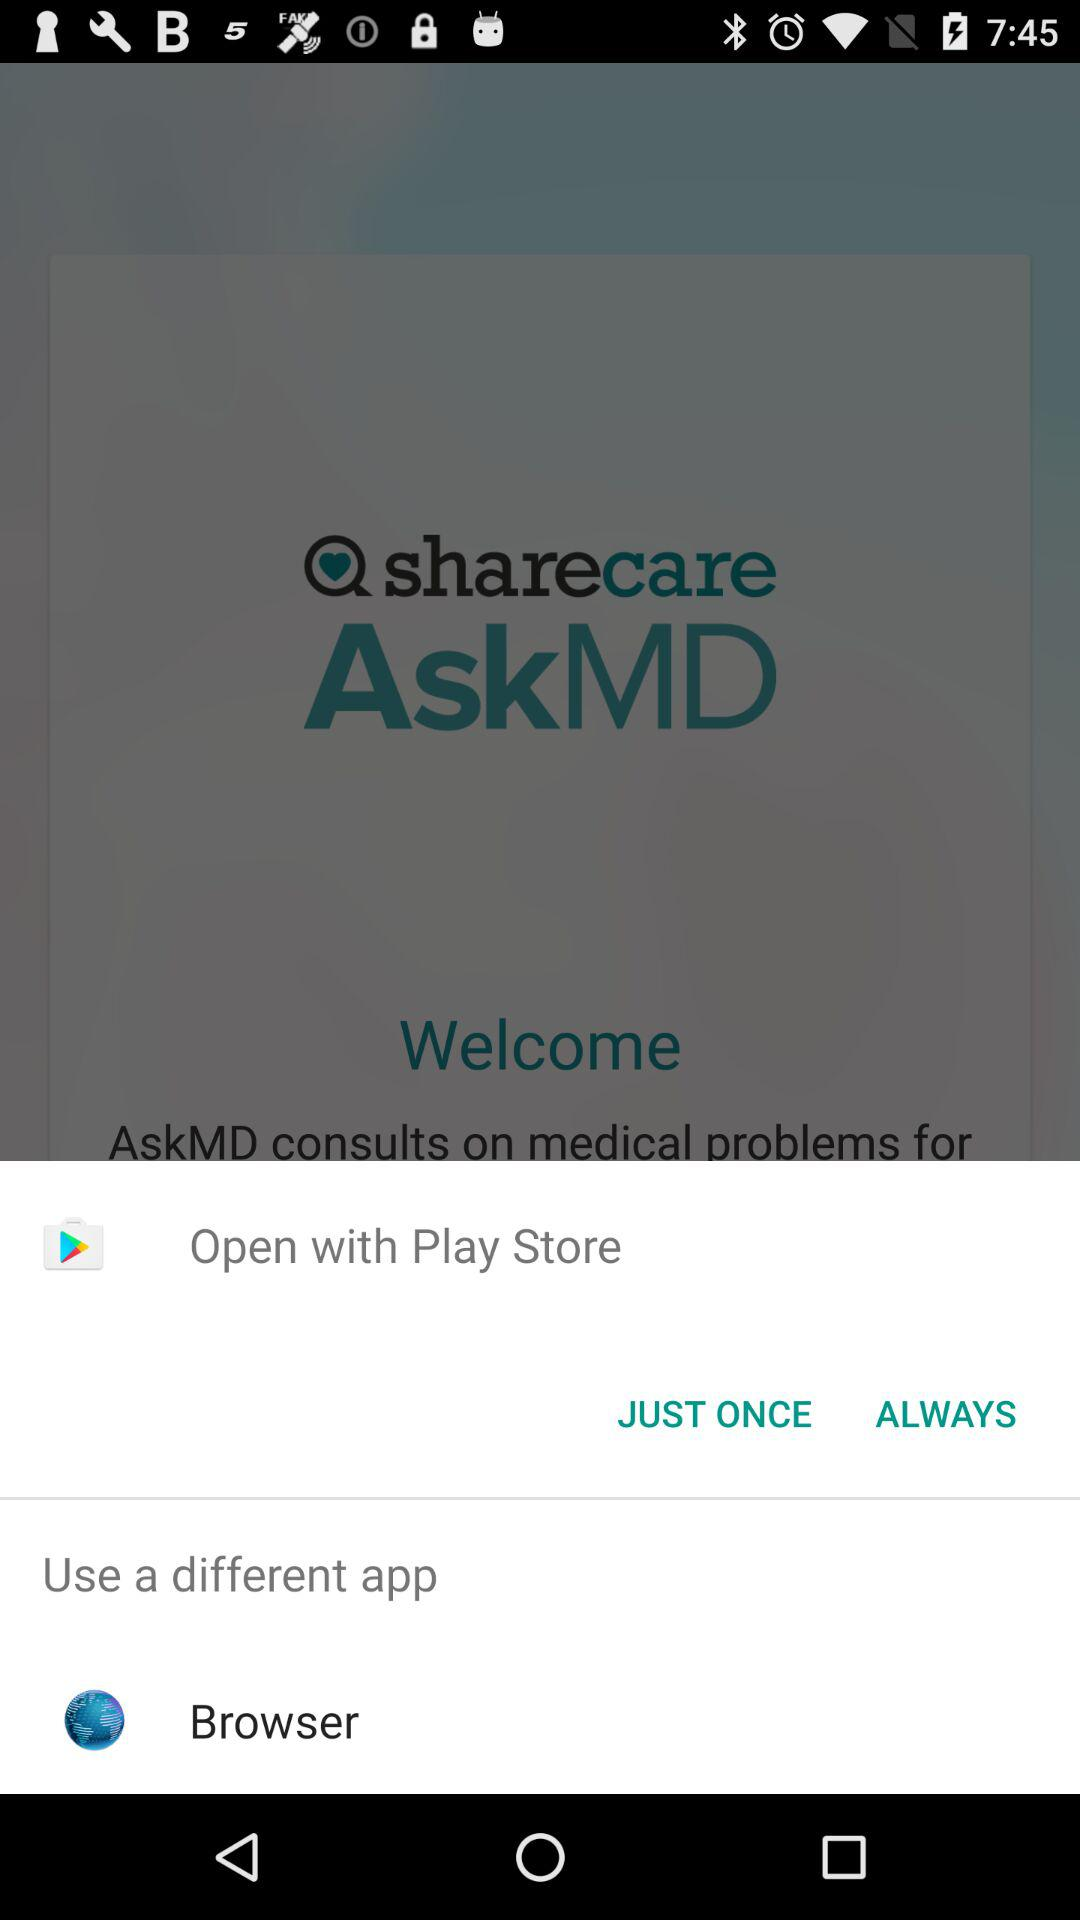Which application can it be opened with? It can be opened with "Play Store" and "Browser". 